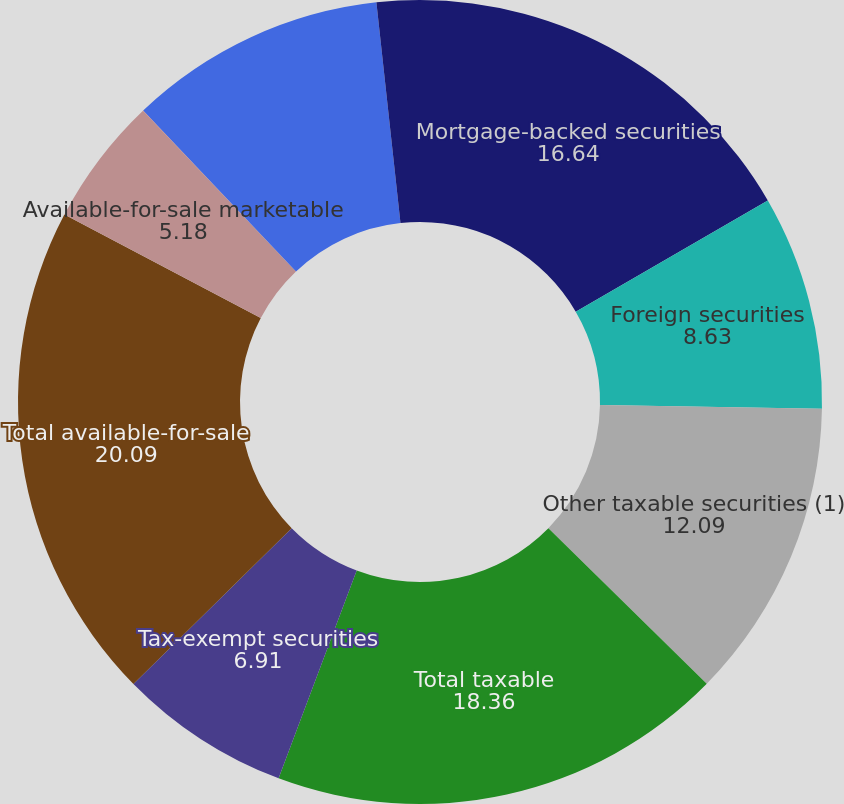Convert chart to OTSL. <chart><loc_0><loc_0><loc_500><loc_500><pie_chart><fcel>Mortgage-backed securities<fcel>Foreign securities<fcel>Other taxable securities (1)<fcel>Total taxable<fcel>Tax-exempt securities<fcel>Total available-for-sale<fcel>Available-for-sale marketable<fcel>US Treasury securities and<fcel>Other taxable securities (3)<fcel>Taxable securities<nl><fcel>16.64%<fcel>8.63%<fcel>12.09%<fcel>18.36%<fcel>6.91%<fcel>20.09%<fcel>5.18%<fcel>0.01%<fcel>10.36%<fcel>1.73%<nl></chart> 